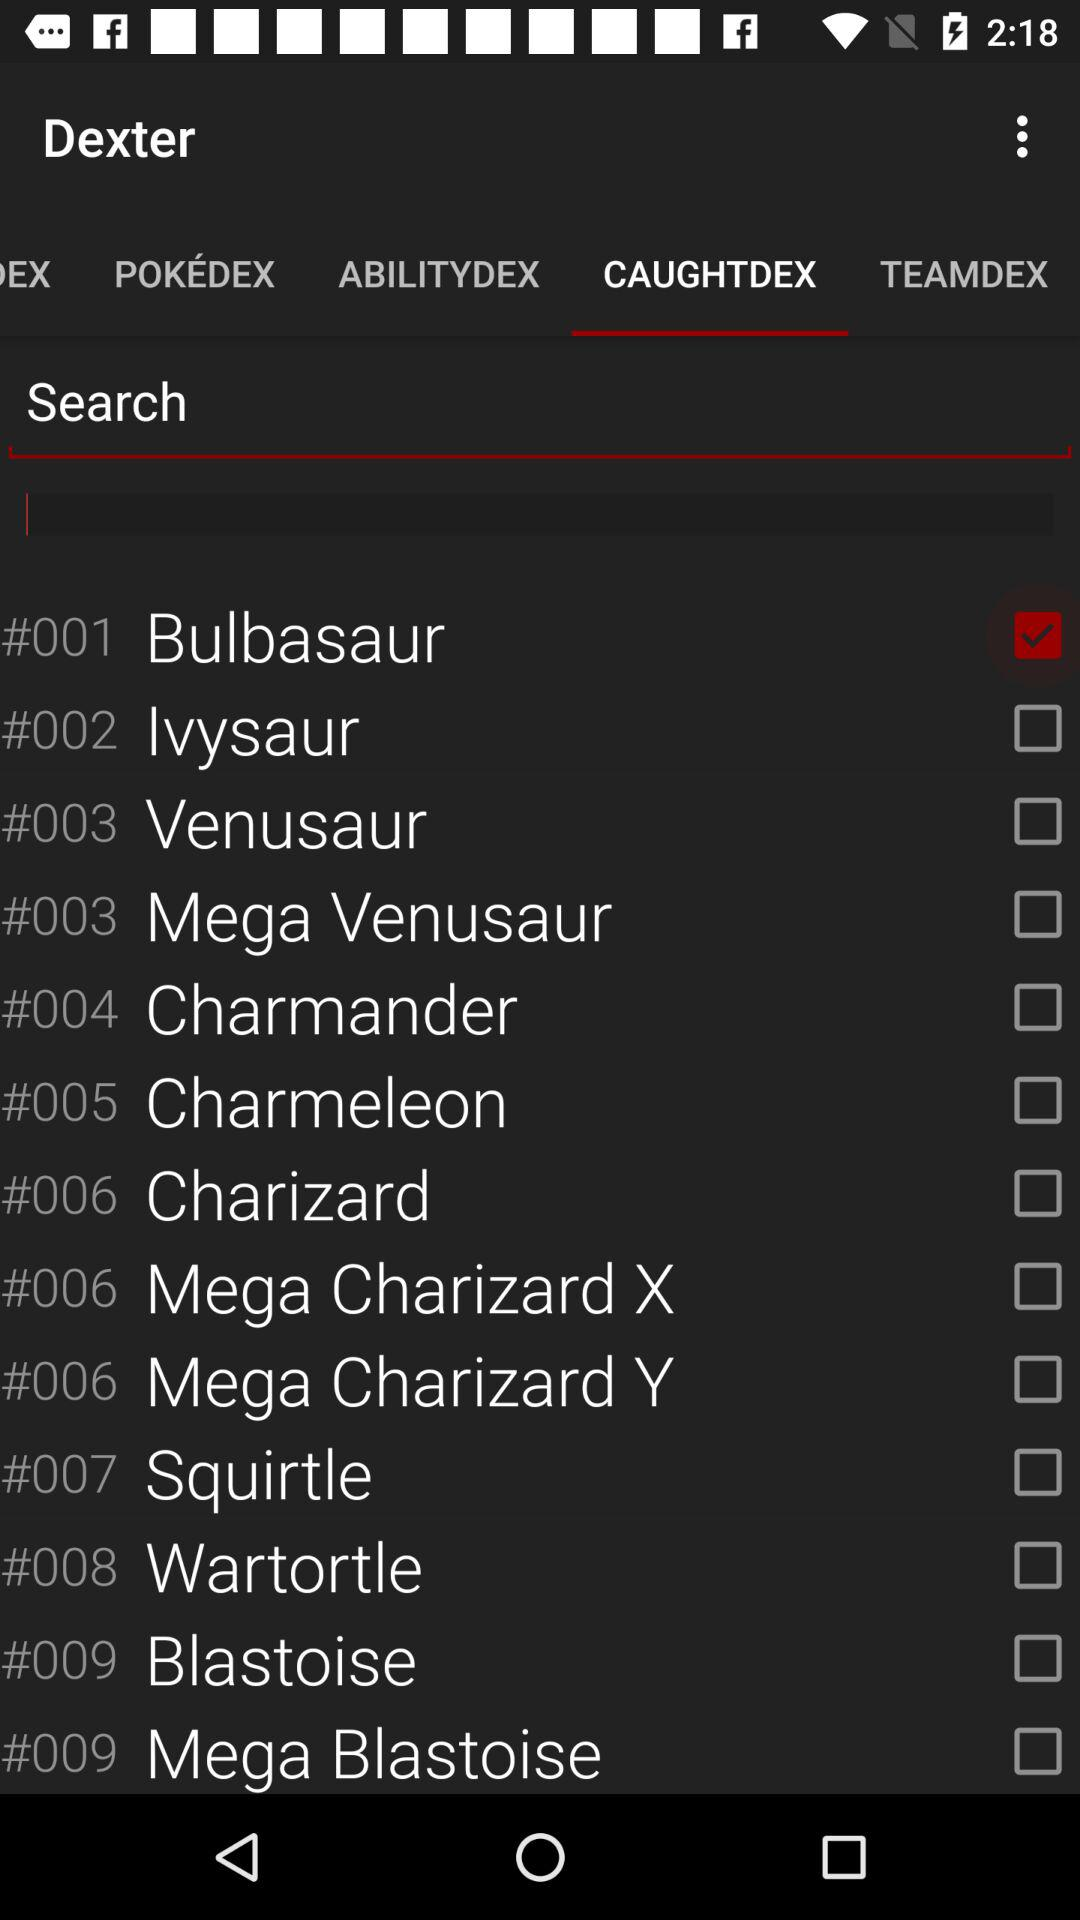What tab is selected? The selected tab is "CAUGHTDEX". 